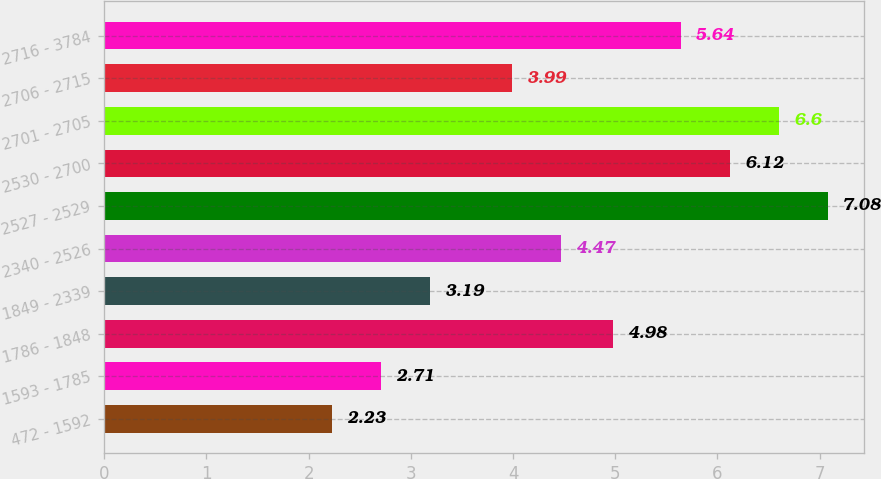<chart> <loc_0><loc_0><loc_500><loc_500><bar_chart><fcel>472 - 1592<fcel>1593 - 1785<fcel>1786 - 1848<fcel>1849 - 2339<fcel>2340 - 2526<fcel>2527 - 2529<fcel>2530 - 2700<fcel>2701 - 2705<fcel>2706 - 2715<fcel>2716 - 3784<nl><fcel>2.23<fcel>2.71<fcel>4.98<fcel>3.19<fcel>4.47<fcel>7.08<fcel>6.12<fcel>6.6<fcel>3.99<fcel>5.64<nl></chart> 